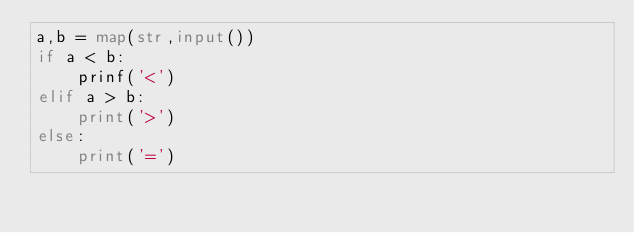<code> <loc_0><loc_0><loc_500><loc_500><_Python_>a,b = map(str,input())
if a < b:
	prinf('<')
elif a > b:
	print('>')
else:
	print('=')</code> 